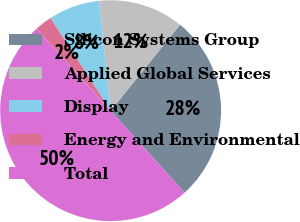Convert chart to OTSL. <chart><loc_0><loc_0><loc_500><loc_500><pie_chart><fcel>Silicon Systems Group<fcel>Applied Global Services<fcel>Display<fcel>Energy and Environmental<fcel>Total<nl><fcel>27.5%<fcel>12.5%<fcel>7.5%<fcel>2.5%<fcel>50.0%<nl></chart> 